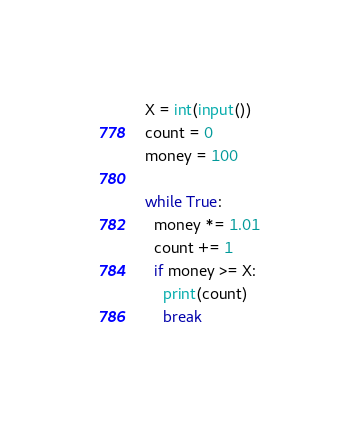<code> <loc_0><loc_0><loc_500><loc_500><_Python_>X = int(input())
count = 0
money = 100

while True:
  money *= 1.01
  count += 1
  if money >= X:
    print(count)
    break
</code> 